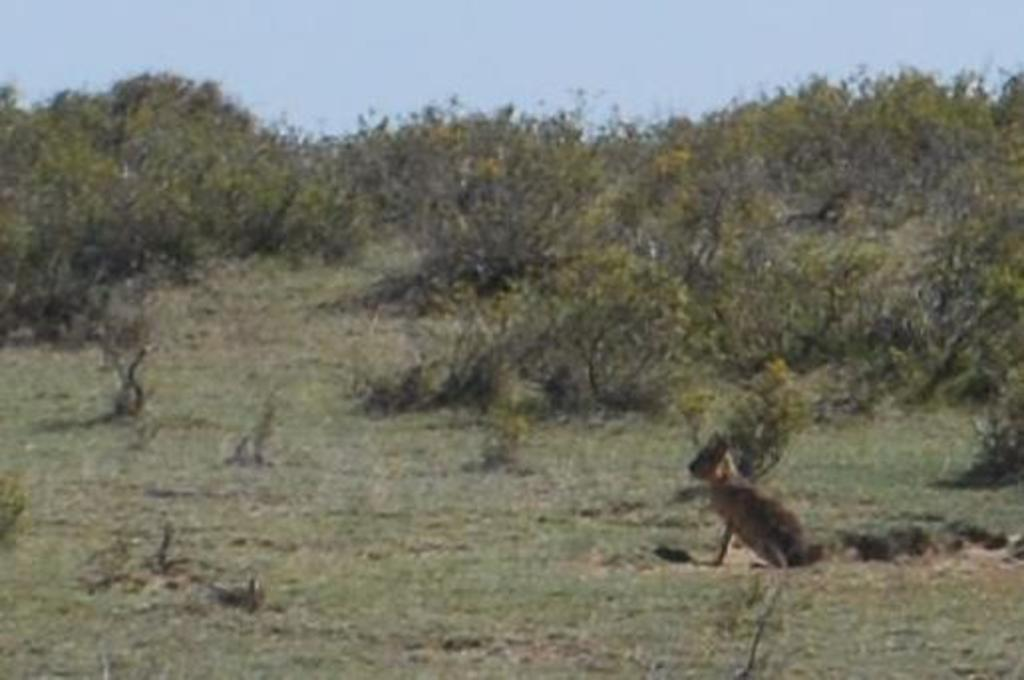What type of animal is in the image? There is an animal in the image, but the specific type cannot be determined from the provided facts. What can be seen in the background of the image? There are trees in the background of the image. What color are the trees? The trees are green. What color is the sky in the image? The sky is blue. What hobbies does the animal in the image enjoy? There is no information about the animal's hobbies in the image or the provided facts. How far away are the trees from the animal in the image? The distance between the animal and the trees cannot be determined from the provided facts. 